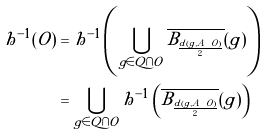Convert formula to latex. <formula><loc_0><loc_0><loc_500><loc_500>h ^ { - 1 } ( O ) & = h ^ { - 1 } \left ( { \bigcup _ { g \in Q \cap O } \overline { B _ { \frac { d ( g , A \ O ) } { 2 } } } ( g ) } \right ) \\ & = \bigcup _ { g \in Q \cap O } h ^ { - 1 } \left ( { \overline { B _ { \frac { d ( g , A \ O ) } { 2 } } } ( g ) } \right )</formula> 